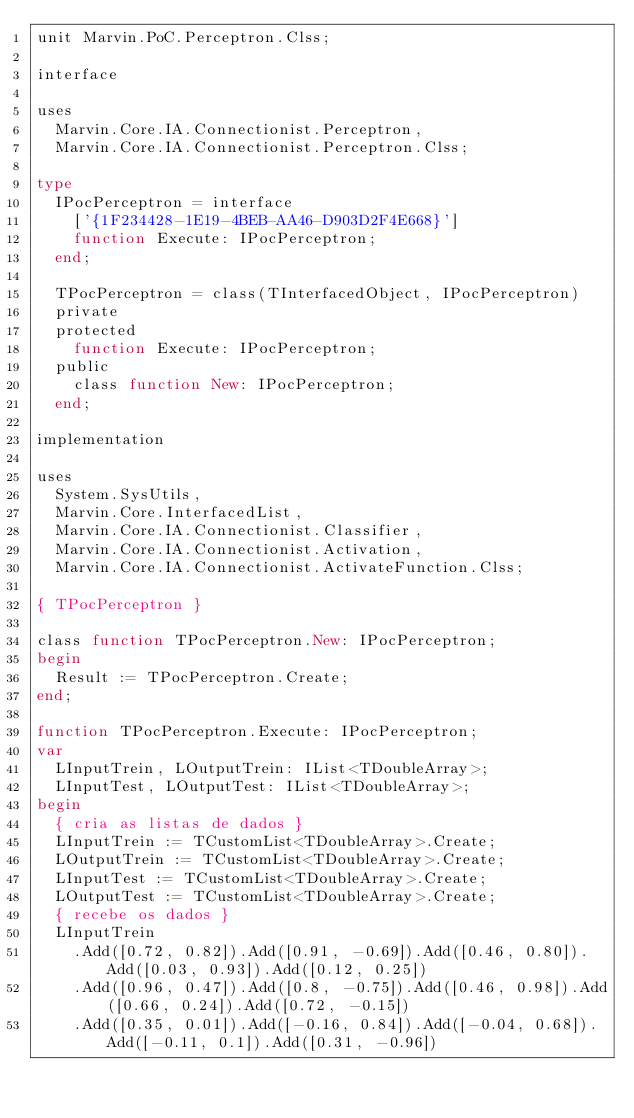Convert code to text. <code><loc_0><loc_0><loc_500><loc_500><_Pascal_>unit Marvin.PoC.Perceptron.Clss;

interface

uses
  Marvin.Core.IA.Connectionist.Perceptron,
  Marvin.Core.IA.Connectionist.Perceptron.Clss;

type
  IPocPerceptron = interface
    ['{1F234428-1E19-4BEB-AA46-D903D2F4E668}']
    function Execute: IPocPerceptron;
  end;

  TPocPerceptron = class(TInterfacedObject, IPocPerceptron)
  private
  protected
    function Execute: IPocPerceptron;
  public
    class function New: IPocPerceptron;
  end;

implementation

uses
  System.SysUtils,
  Marvin.Core.InterfacedList,
  Marvin.Core.IA.Connectionist.Classifier,
  Marvin.Core.IA.Connectionist.Activation,
  Marvin.Core.IA.Connectionist.ActivateFunction.Clss;

{ TPocPerceptron }

class function TPocPerceptron.New: IPocPerceptron;
begin
  Result := TPocPerceptron.Create;
end;

function TPocPerceptron.Execute: IPocPerceptron;
var
  LInputTrein, LOutputTrein: IList<TDoubleArray>;
  LInputTest, LOutputTest: IList<TDoubleArray>;
begin
  { cria as listas de dados }
  LInputTrein := TCustomList<TDoubleArray>.Create;
  LOutputTrein := TCustomList<TDoubleArray>.Create;
  LInputTest := TCustomList<TDoubleArray>.Create;
  LOutputTest := TCustomList<TDoubleArray>.Create;
  { recebe os dados }
  LInputTrein
    .Add([0.72, 0.82]).Add([0.91, -0.69]).Add([0.46, 0.80]).Add([0.03, 0.93]).Add([0.12, 0.25])
    .Add([0.96, 0.47]).Add([0.8, -0.75]).Add([0.46, 0.98]).Add([0.66, 0.24]).Add([0.72, -0.15])
    .Add([0.35, 0.01]).Add([-0.16, 0.84]).Add([-0.04, 0.68]).Add([-0.11, 0.1]).Add([0.31, -0.96])</code> 